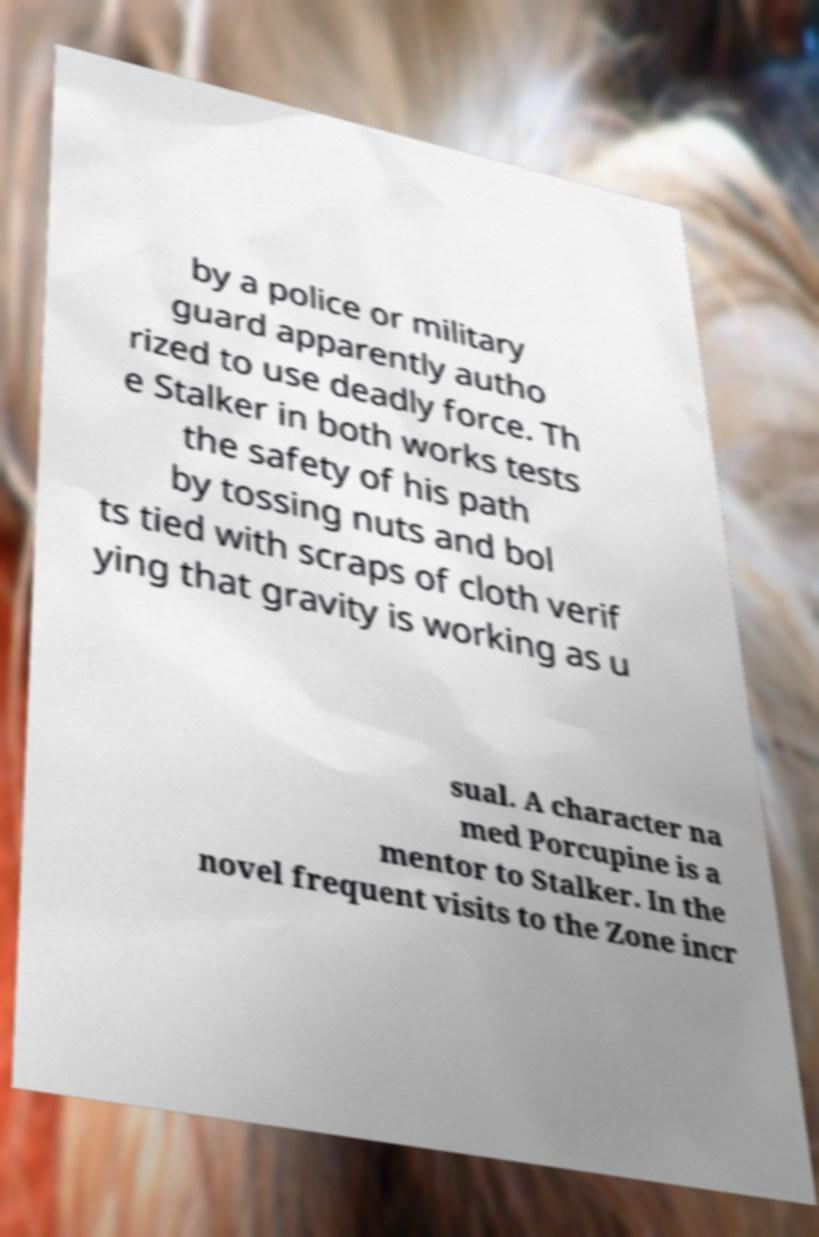Please identify and transcribe the text found in this image. by a police or military guard apparently autho rized to use deadly force. Th e Stalker in both works tests the safety of his path by tossing nuts and bol ts tied with scraps of cloth verif ying that gravity is working as u sual. A character na med Porcupine is a mentor to Stalker. In the novel frequent visits to the Zone incr 